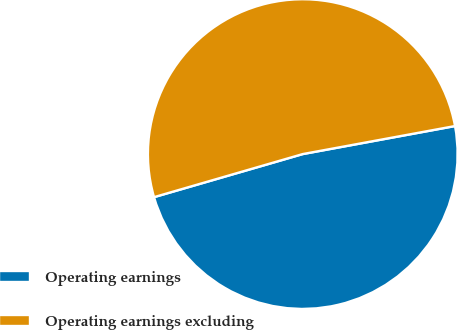<chart> <loc_0><loc_0><loc_500><loc_500><pie_chart><fcel>Operating earnings<fcel>Operating earnings excluding<nl><fcel>48.41%<fcel>51.59%<nl></chart> 